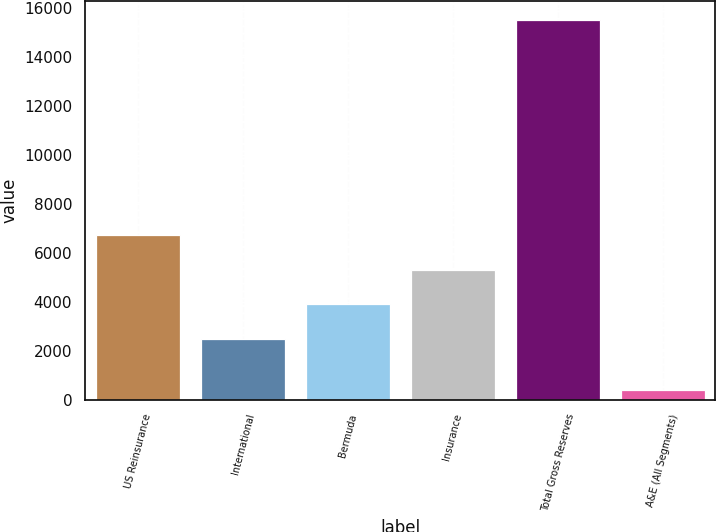Convert chart to OTSL. <chart><loc_0><loc_0><loc_500><loc_500><bar_chart><fcel>US Reinsurance<fcel>International<fcel>Bermuda<fcel>Insurance<fcel>Total Gross Reserves<fcel>A&E (All Segments)<nl><fcel>6713.75<fcel>2485.7<fcel>3895.05<fcel>5304.4<fcel>15526<fcel>395.1<nl></chart> 